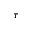Convert formula to latex. <formula><loc_0><loc_0><loc_500><loc_500>\tau</formula> 